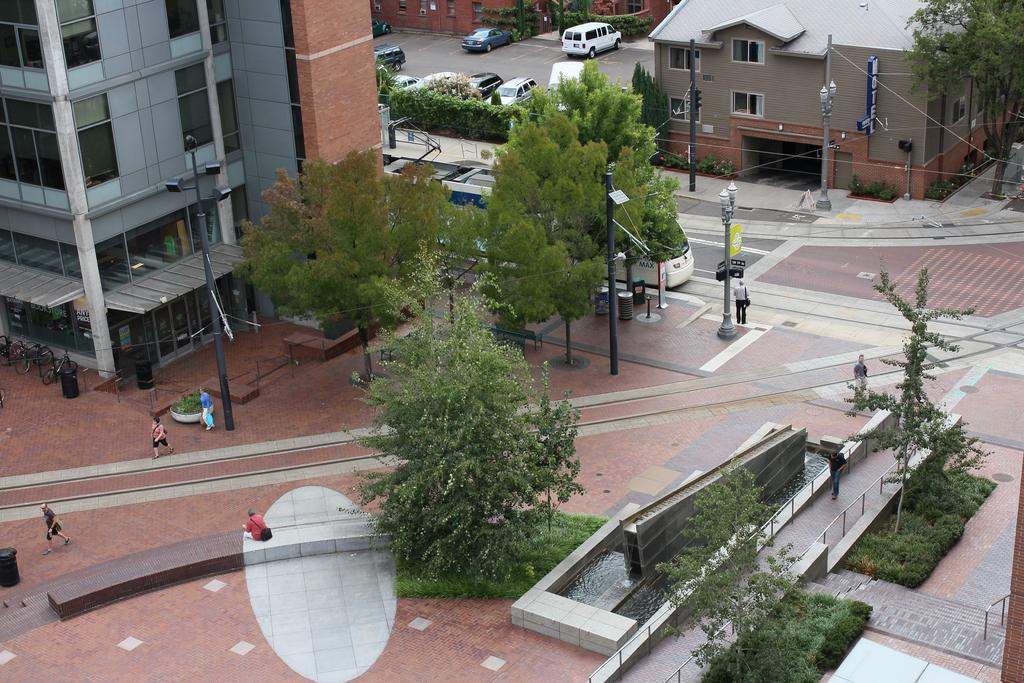What is the perspective of the image? The image is taken from a top angle. What type of natural elements can be seen in the image? There are trees in the image. What type of man-made structures are visible in the image? There are roads, buildings, and poles in the image. What type of vehicles can be seen in the image? There are cars in the image. Are there any people present in the image? Yes, there are people in the image. What type of whip is being used by the person in the image? There is no whip present in the image; it features a top-down view of a scene with trees, roads, buildings, cars, and people. 